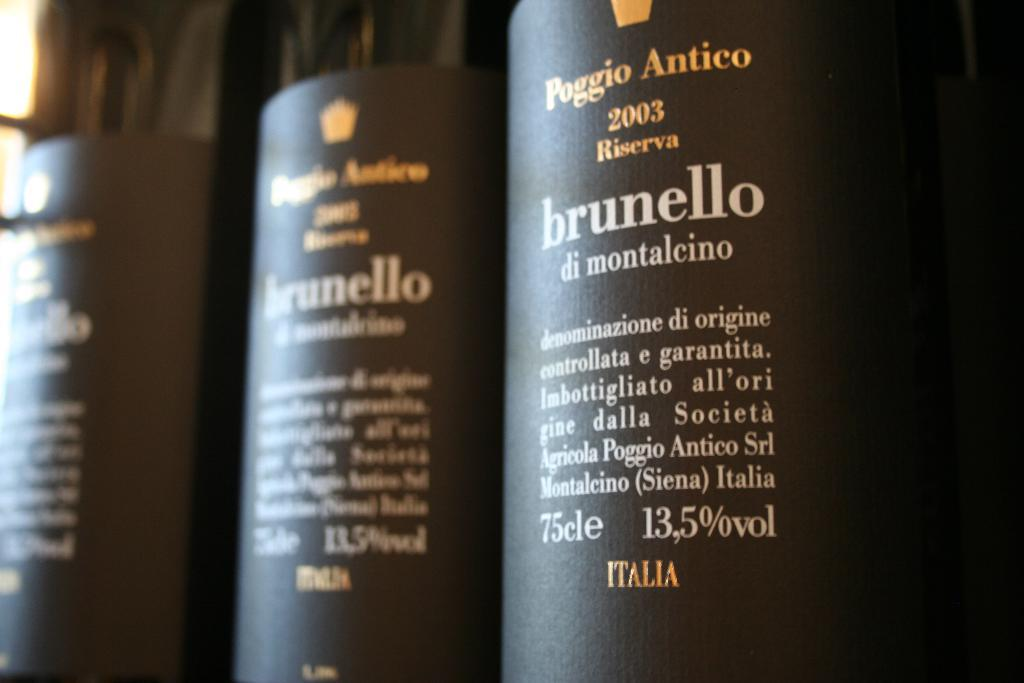Provide a one-sentence caption for the provided image. A row of bottles of Poggio Antico wine on a store shelf. 